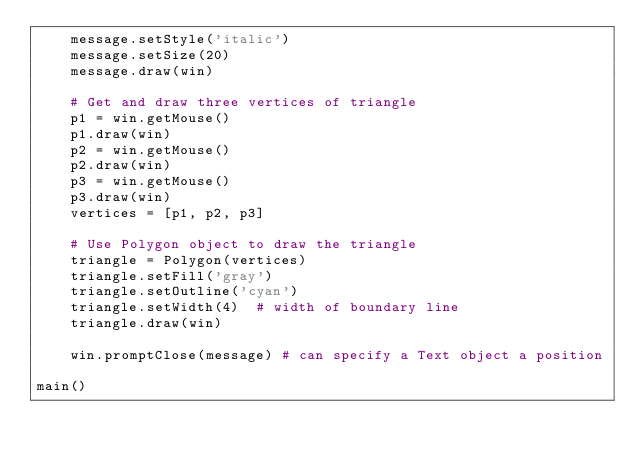<code> <loc_0><loc_0><loc_500><loc_500><_Python_>    message.setStyle('italic')
    message.setSize(20)
    message.draw(win)

    # Get and draw three vertices of triangle
    p1 = win.getMouse()
    p1.draw(win)
    p2 = win.getMouse()
    p2.draw(win)
    p3 = win.getMouse()
    p3.draw(win)
    vertices = [p1, p2, p3]

    # Use Polygon object to draw the triangle
    triangle = Polygon(vertices)
    triangle.setFill('gray')
    triangle.setOutline('cyan')
    triangle.setWidth(4)  # width of boundary line
    triangle.draw(win)

    win.promptClose(message) # can specify a Text object a position

main()
</code> 